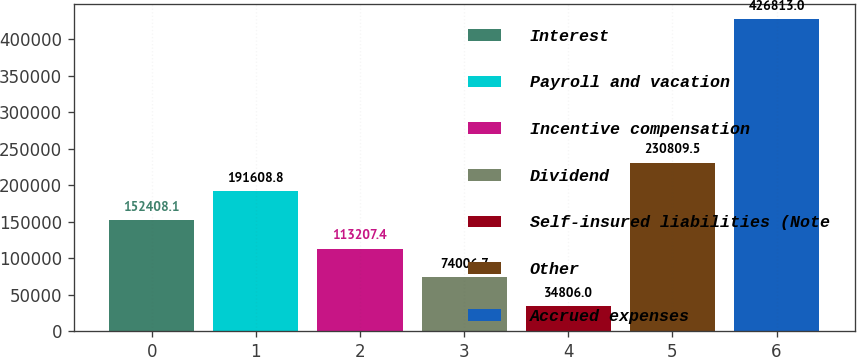<chart> <loc_0><loc_0><loc_500><loc_500><bar_chart><fcel>Interest<fcel>Payroll and vacation<fcel>Incentive compensation<fcel>Dividend<fcel>Self-insured liabilities (Note<fcel>Other<fcel>Accrued expenses<nl><fcel>152408<fcel>191609<fcel>113207<fcel>74006.7<fcel>34806<fcel>230810<fcel>426813<nl></chart> 